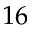<formula> <loc_0><loc_0><loc_500><loc_500>1 6</formula> 